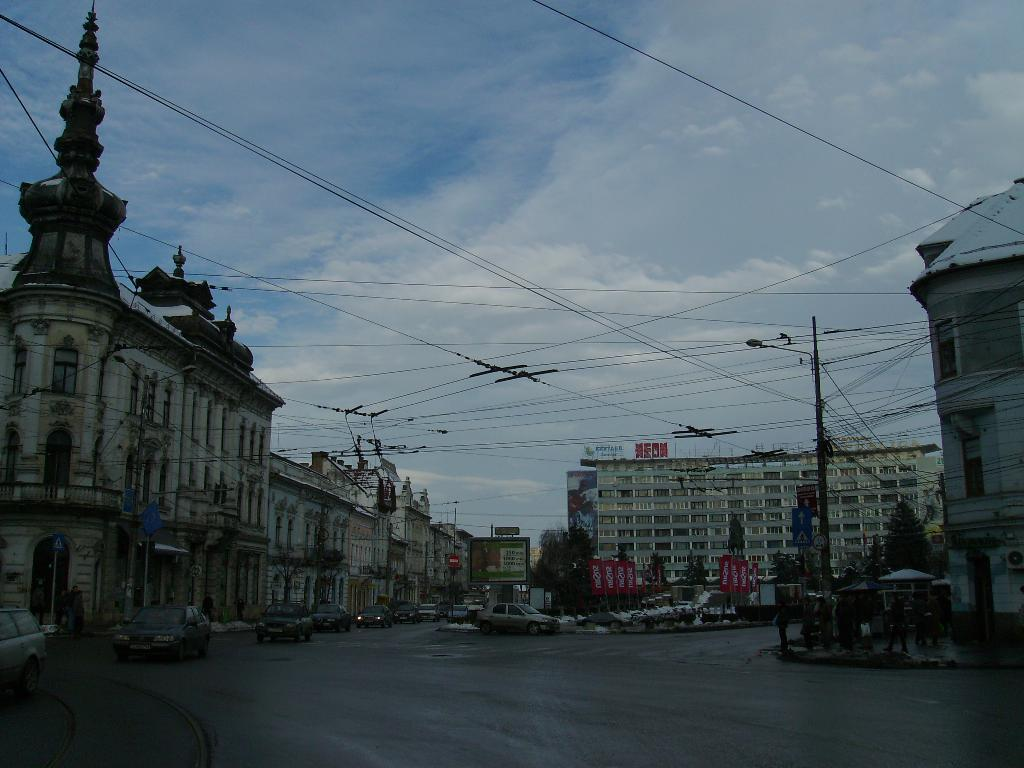What is happening in the foreground of the image? There are vehicles moving on the road in the foreground of the image. What can be seen in the background of the image? There are buildings, cables, poles, flags, and the sky visible in the background of the image. What is the condition of the sky in the image? The sky is visible in the background of the image, and clouds are present in the sky. What type of space exploration is depicted in the image? There is no space exploration depicted in the image; it features vehicles moving on a road, buildings, and other elements in the background. How does the team interact with the cables in the image? There is no team present in the image, and the cables are not being interacted with by any individuals. 